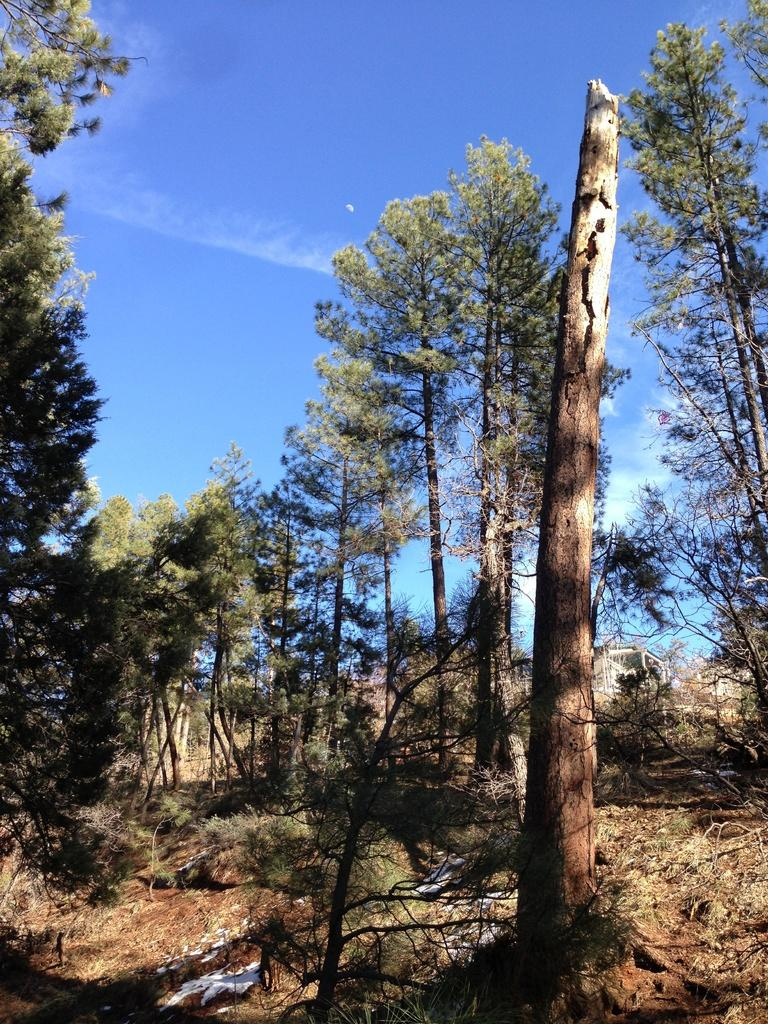What type of vegetation can be seen in the image? There are trees in the image. What is the condition of the ground in the image? The ground in the image has dry grass. What can be seen in the sky in the image? There are clouds visible in the sky in the image. What color is the toe of the person in the image? There is no person present in the image, so there is no toe to observe. 